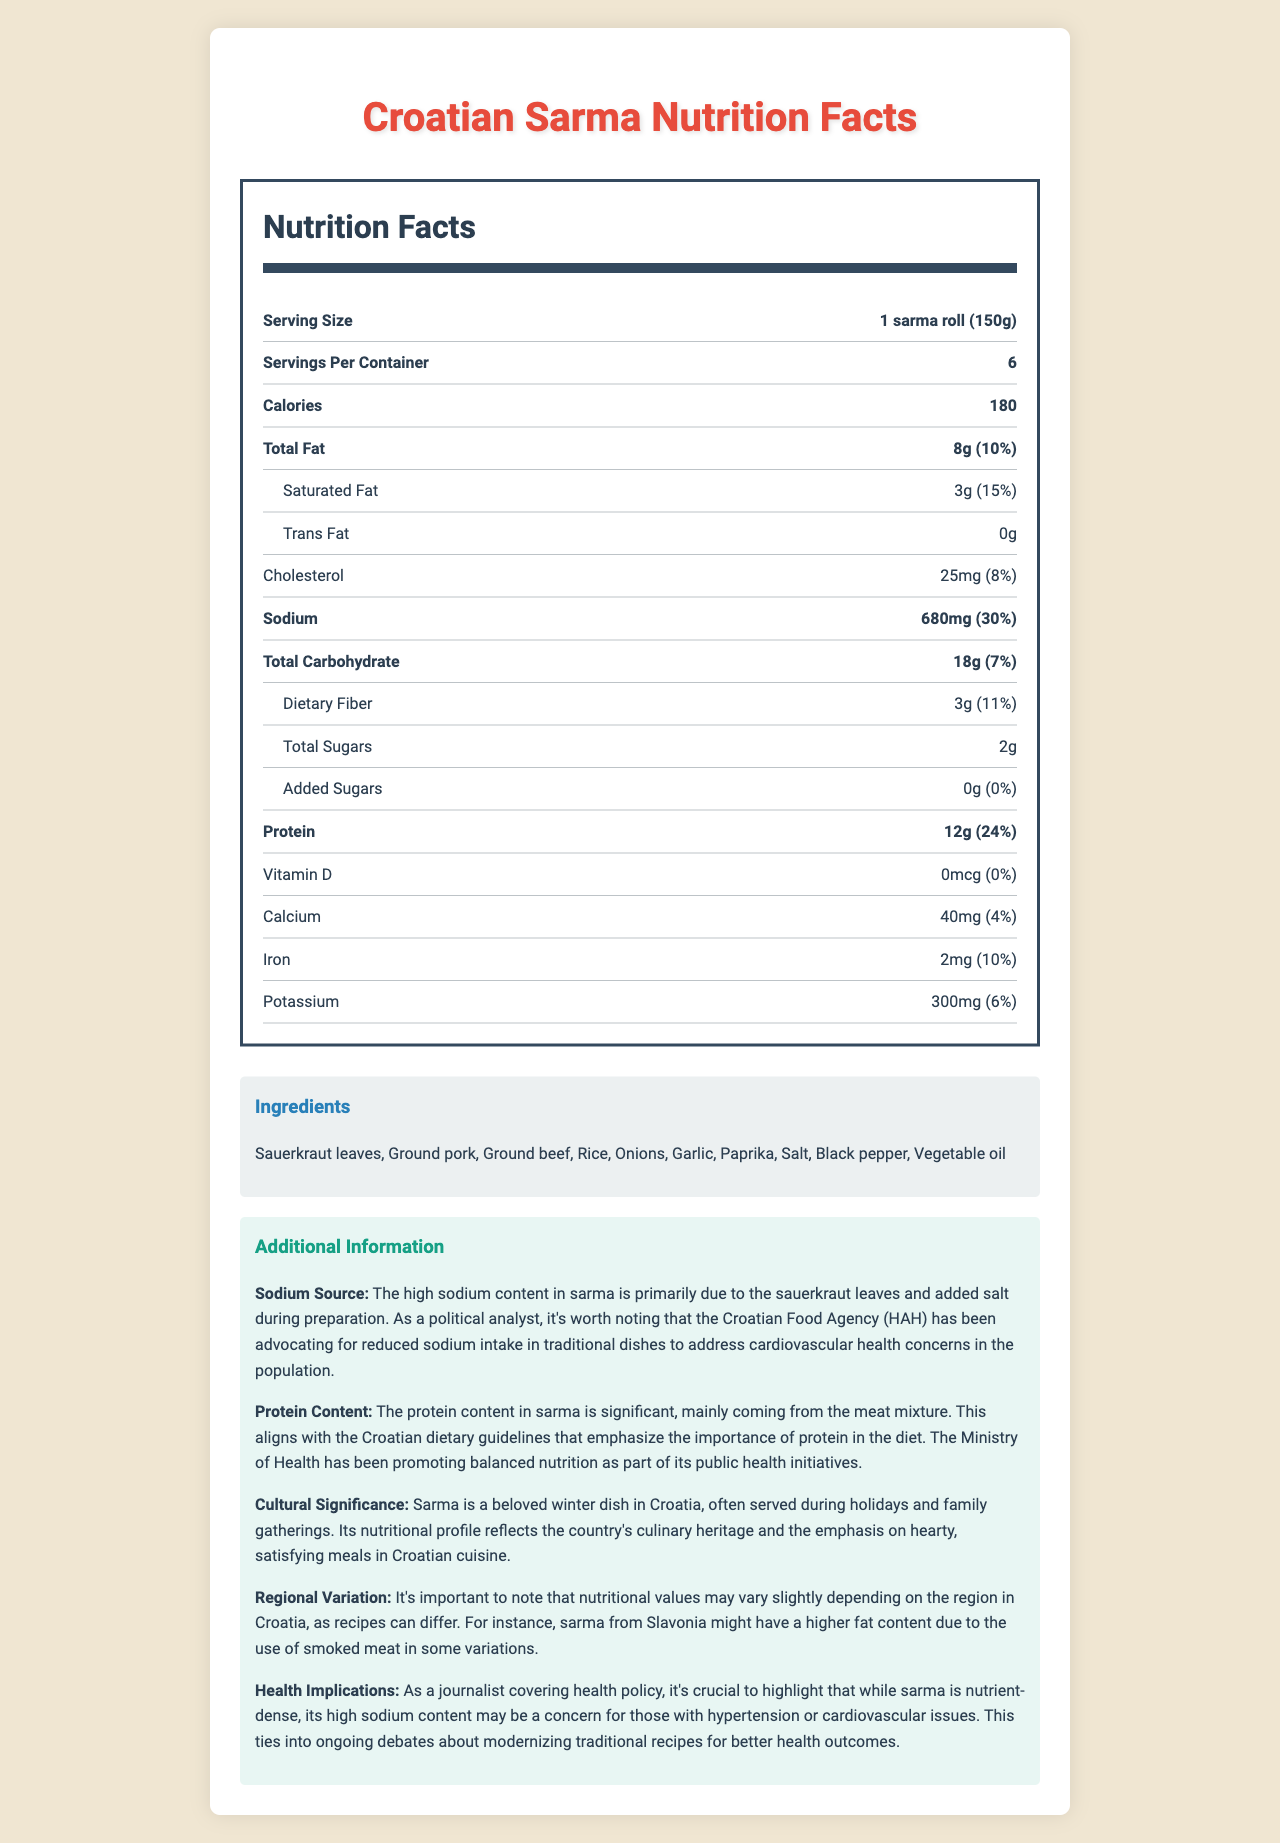what is the serving size for one sarma roll? The serving size is explicitly mentioned as "1 sarma roll (150g)" in the Nutrition Facts section.
Answer: 1 sarma roll (150g) how many servings are there per container? The label specifies that there are 6 servings per container.
Answer: 6 what is the main source of the high sodium content in sarma? This information is provided in the additional information under "Sodium Source."
Answer: Sauerkraut leaves and added salt during preparation how much protein is there in one serving of sarma? The protein content per serving is listed as 12g in the document.
Answer: 12g what percentage of the daily protein recommendation does one serving of sarma provide? The document states that the protein content provides 24% of the daily value per serving.
Answer: 24% how many calories are there per serving of sarma? The calorie content per serving is 180 calories as mentioned in the Nutrition Facts.
Answer: 180 which of the following ingredients is not part of the sarma dish? A. Sauerkraut leaves B. Ground turkey C. Rice D. Onions The list of ingredients includes "Ground pork" and "Ground beef" but does not include "Ground turkey."
Answer: B. Ground turkey what is the amount of dietary fiber in one serving of sarma? A. 5g B. 8g C. 3g D. 10g The document lists dietary fiber as 3g per serving.
Answer: C. 3g does the sarma dish contain any allergens? The document specifies "None" under the Allergens section.
Answer: No is there any added sugars in sarma? The document specifies that added sugars amount is 0g and 0% of daily value.
Answer: No summarize the key nutritional points of the sarma dish. The summary covers the nutritional profile, cultural significance, and health implications as detailed in the document.
Answer: Croatian Sarma is a high-protein dish with significant sodium content, which comes from sauerkraut leaves and added salt. It is culturally significant and often consumed during family gatherings and holidays. While nutrient-dense, its high sodium content poses health concerns for those with hypertension or cardiovascular issues. what does the Croatian Ministry of Health promote regarding protein intake? The document mentions that the Ministry of Health promotes balanced nutrition but does not provide specific details on their stance regarding protein intake.
Answer: Not enough information 